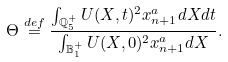Convert formula to latex. <formula><loc_0><loc_0><loc_500><loc_500>\Theta \overset { d e f } { = } \frac { \int _ { \mathbb { Q } _ { 5 } ^ { + } } U ( X , t ) ^ { 2 } x _ { n + 1 } ^ { a } d X d t } { \int _ { \mathbb { B } _ { 1 } ^ { + } } U ( X , 0 ) ^ { 2 } x _ { n + 1 } ^ { a } d X } .</formula> 